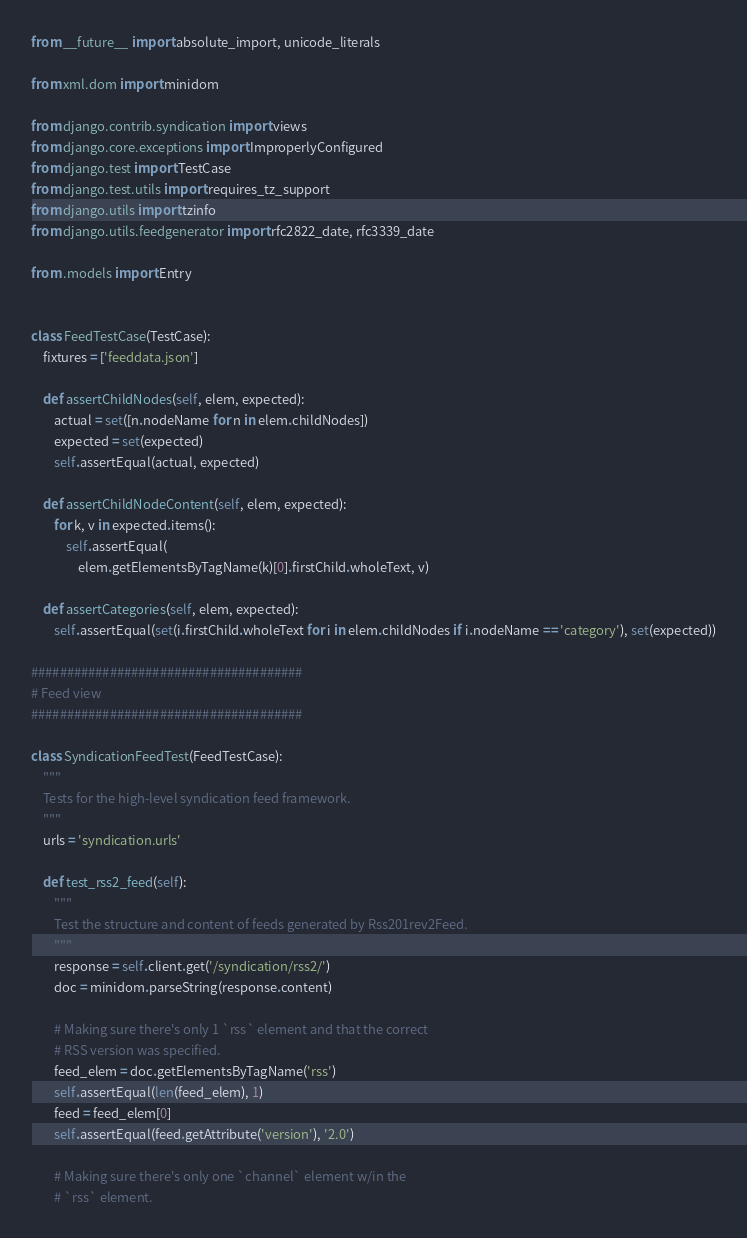Convert code to text. <code><loc_0><loc_0><loc_500><loc_500><_Python_>from __future__ import absolute_import, unicode_literals

from xml.dom import minidom

from django.contrib.syndication import views
from django.core.exceptions import ImproperlyConfigured
from django.test import TestCase
from django.test.utils import requires_tz_support
from django.utils import tzinfo
from django.utils.feedgenerator import rfc2822_date, rfc3339_date

from .models import Entry


class FeedTestCase(TestCase):
    fixtures = ['feeddata.json']

    def assertChildNodes(self, elem, expected):
        actual = set([n.nodeName for n in elem.childNodes])
        expected = set(expected)
        self.assertEqual(actual, expected)

    def assertChildNodeContent(self, elem, expected):
        for k, v in expected.items():
            self.assertEqual(
                elem.getElementsByTagName(k)[0].firstChild.wholeText, v)

    def assertCategories(self, elem, expected):
        self.assertEqual(set(i.firstChild.wholeText for i in elem.childNodes if i.nodeName == 'category'), set(expected))

######################################
# Feed view
######################################

class SyndicationFeedTest(FeedTestCase):
    """
    Tests for the high-level syndication feed framework.
    """
    urls = 'syndication.urls'

    def test_rss2_feed(self):
        """
        Test the structure and content of feeds generated by Rss201rev2Feed.
        """
        response = self.client.get('/syndication/rss2/')
        doc = minidom.parseString(response.content)

        # Making sure there's only 1 `rss` element and that the correct
        # RSS version was specified.
        feed_elem = doc.getElementsByTagName('rss')
        self.assertEqual(len(feed_elem), 1)
        feed = feed_elem[0]
        self.assertEqual(feed.getAttribute('version'), '2.0')

        # Making sure there's only one `channel` element w/in the
        # `rss` element.</code> 